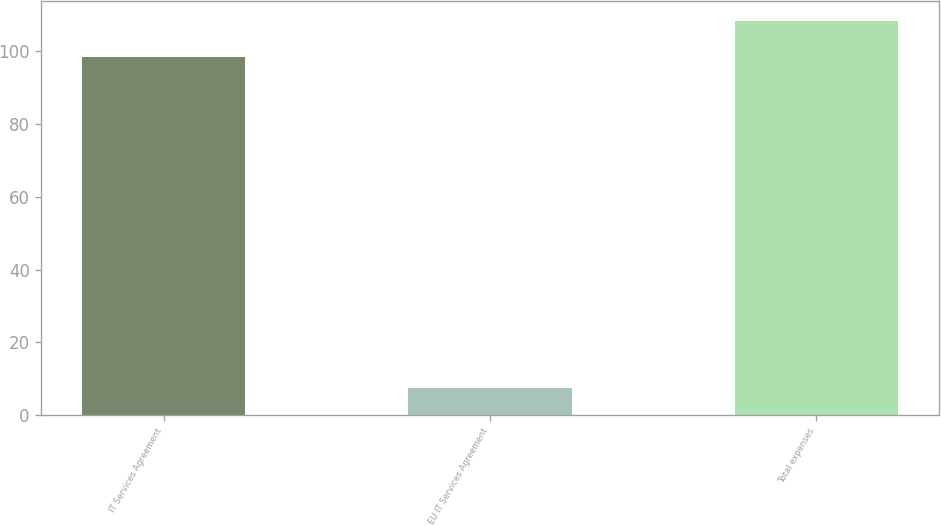Convert chart. <chart><loc_0><loc_0><loc_500><loc_500><bar_chart><fcel>IT Services Agreement<fcel>EU IT Services Agreement<fcel>Total expenses<nl><fcel>98.5<fcel>7.5<fcel>108.35<nl></chart> 